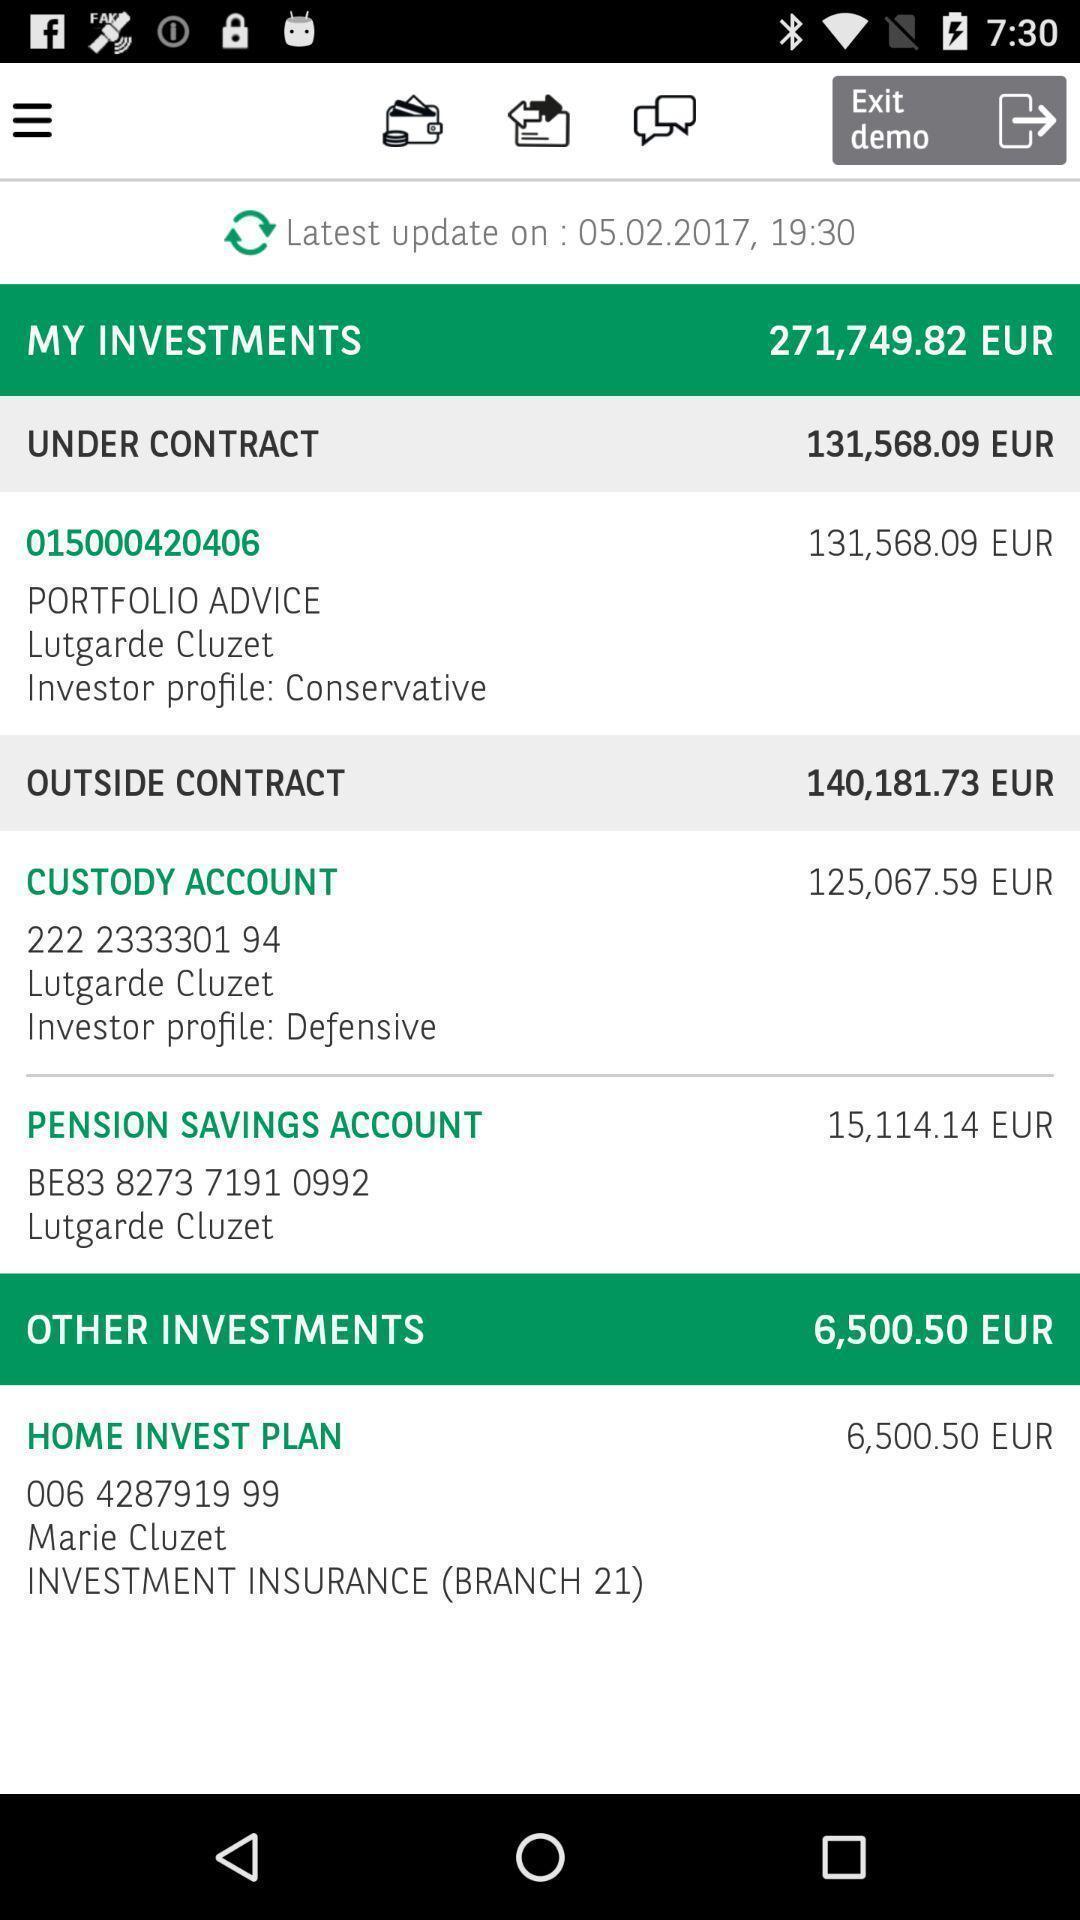Explain the elements present in this screenshot. Page displaying the investments. 